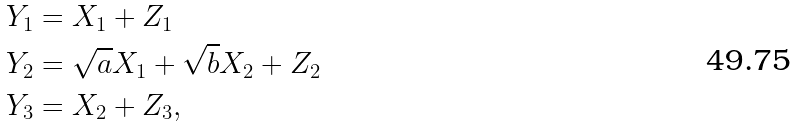<formula> <loc_0><loc_0><loc_500><loc_500>Y _ { 1 } & = X _ { 1 } + Z _ { 1 } \\ Y _ { 2 } & = \sqrt { a } X _ { 1 } + \sqrt { b } X _ { 2 } + Z _ { 2 } \\ Y _ { 3 } & = X _ { 2 } + Z _ { 3 } ,</formula> 